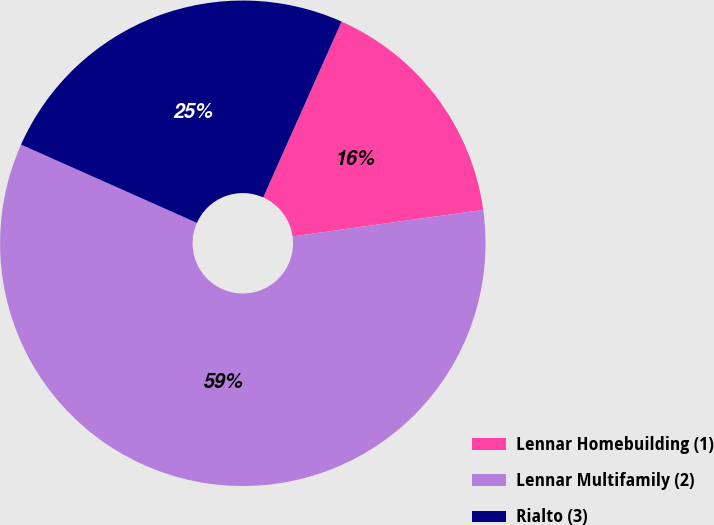Convert chart. <chart><loc_0><loc_0><loc_500><loc_500><pie_chart><fcel>Lennar Homebuilding (1)<fcel>Lennar Multifamily (2)<fcel>Rialto (3)<nl><fcel>16.13%<fcel>58.86%<fcel>25.01%<nl></chart> 